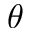<formula> <loc_0><loc_0><loc_500><loc_500>\theta</formula> 